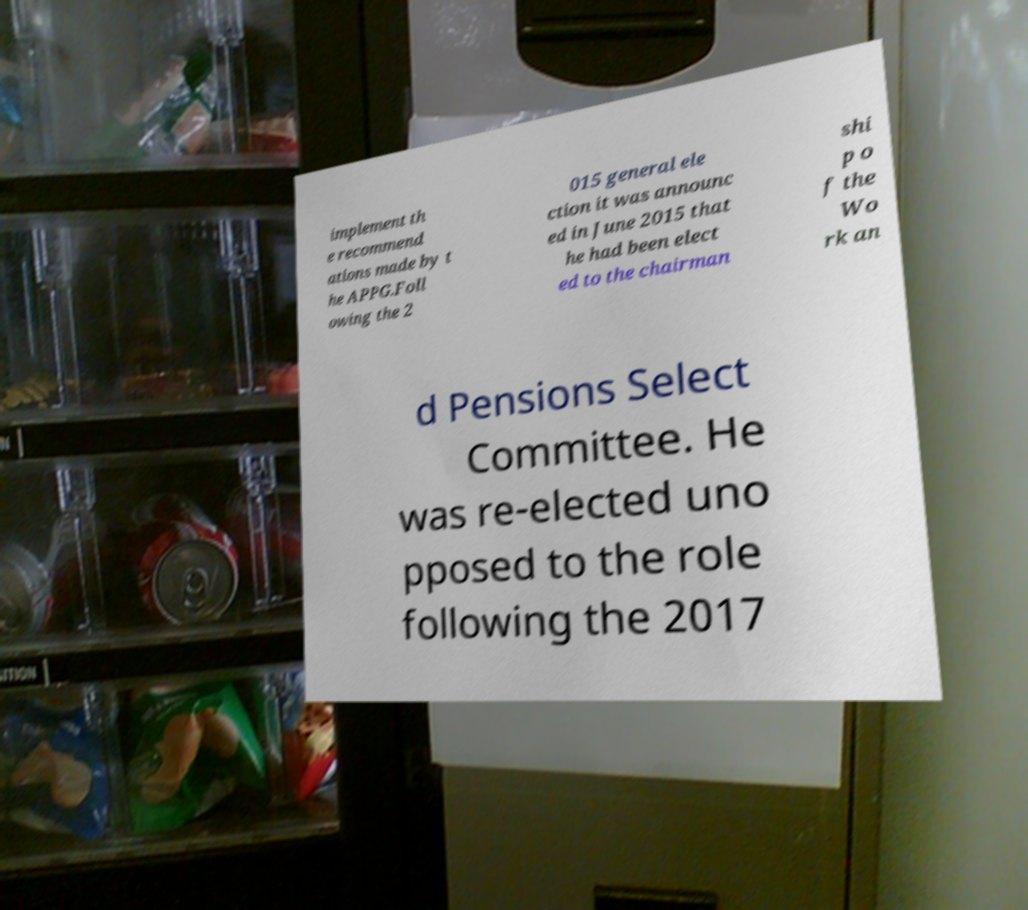What messages or text are displayed in this image? I need them in a readable, typed format. implement th e recommend ations made by t he APPG.Foll owing the 2 015 general ele ction it was announc ed in June 2015 that he had been elect ed to the chairman shi p o f the Wo rk an d Pensions Select Committee. He was re-elected uno pposed to the role following the 2017 